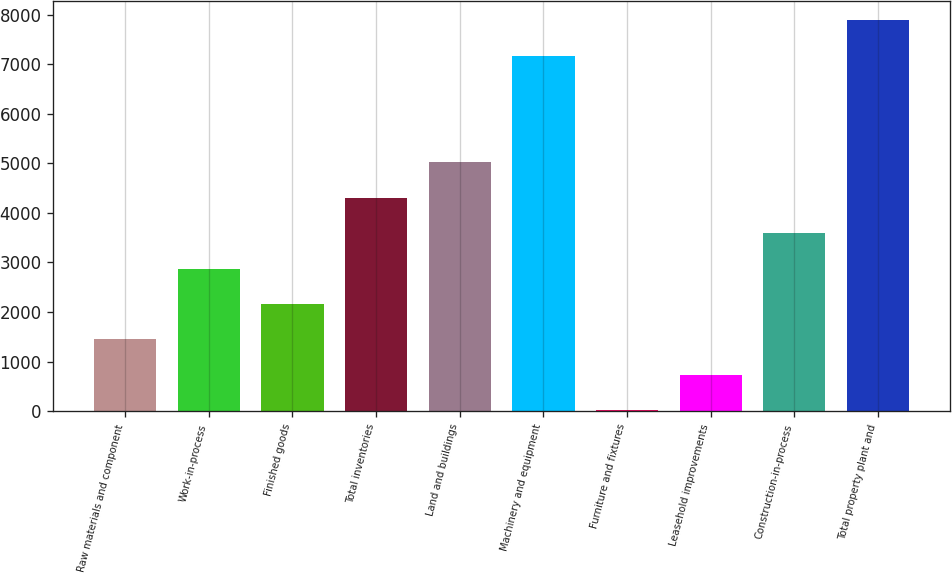Convert chart to OTSL. <chart><loc_0><loc_0><loc_500><loc_500><bar_chart><fcel>Raw materials and component<fcel>Work-in-process<fcel>Finished goods<fcel>Total inventories<fcel>Land and buildings<fcel>Machinery and equipment<fcel>Furniture and fixtures<fcel>Leasehold improvements<fcel>Construction-in-process<fcel>Total property plant and<nl><fcel>1446.6<fcel>2878.2<fcel>2162.4<fcel>4309.8<fcel>5025.6<fcel>7173<fcel>15<fcel>730.8<fcel>3594<fcel>7888.8<nl></chart> 